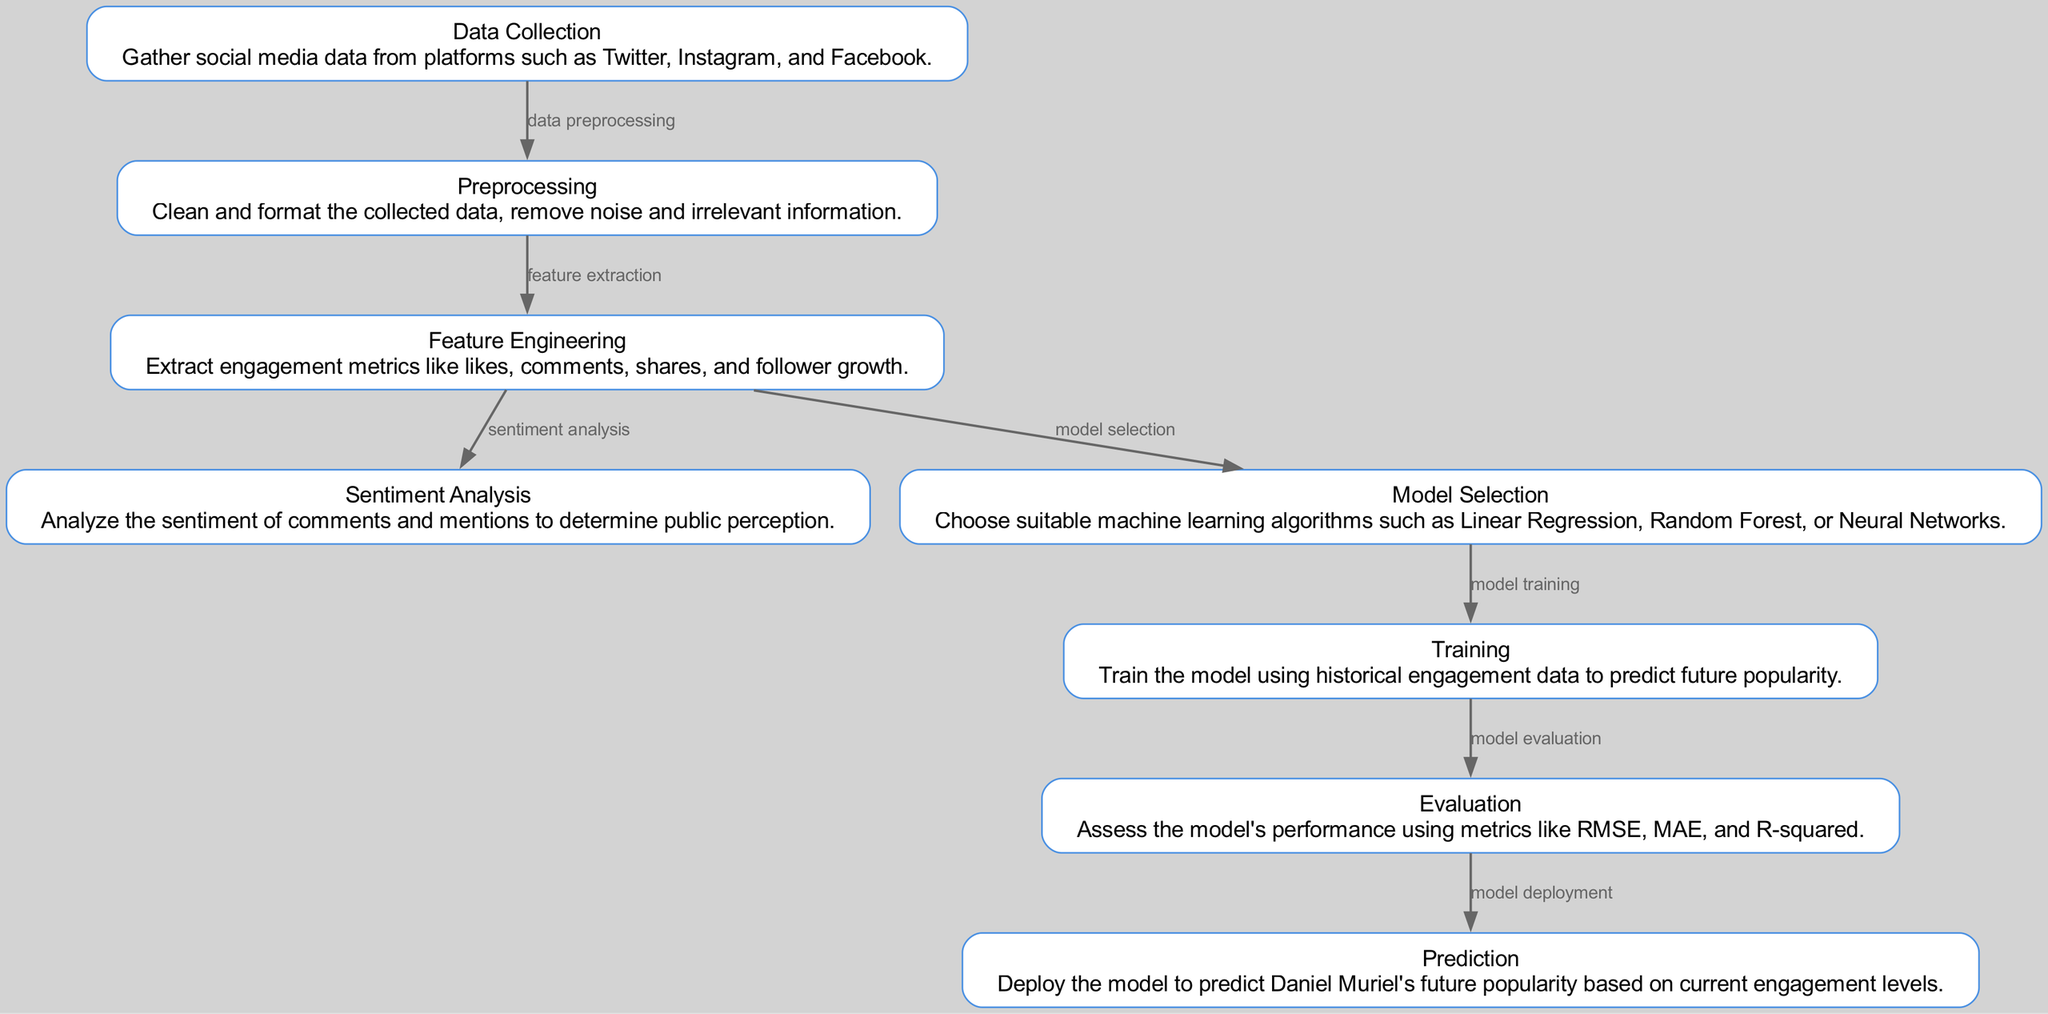What is the first step in the process? The first step or node in the diagram is labeled "Data Collection," which is where the initial gathering of social media data takes place.
Answer: Data Collection How many nodes are in the diagram? By counting the individual nodes listed in the diagram, we find there are a total of eight nodes representing different steps in the machine learning process.
Answer: Eight What is the relationship between the "Preprocessing" and "Feature Engineering" nodes? The diagram shows an edge labeled "feature extraction" connecting "Preprocessing" to "Feature Engineering," indicating that feature engineering occurs after preprocessing.
Answer: feature extraction Which machine learning algorithms are mentioned for model selection? The node labeled "Model Selection" indicates that Linear Regression, Random Forest, and Neural Networks are the suitable machine learning algorithms chosen for this process.
Answer: Linear Regression, Random Forest, Neural Networks What is the final step of the model process? The last node in the diagram, labeled "Prediction," represents the final step where the model is deployed to predict Daniel Muriel's future popularity based on current engagement levels.
Answer: Prediction How does "Sentiment Analysis" relate to "Feature Engineering"? The edge from "Feature Engineering" to "Sentiment Analysis" signifies that after engagement metrics are extracted, sentiment analysis is conducted to understand public perception related to these features.
Answer: Sentiment Analysis What evaluation metrics are used for assessing the model? The node marked "Evaluation" mentions metrics such as RMSE, MAE, and R-squared, which are standard for assessing the performance of regression models in machine learning.
Answer: RMSE, MAE, R-squared Which process follows "Training" in the diagram? The edge leading from "Training" to "Evaluation" indicates that after the model training phase, the following step is to evaluate the model's performance with various metrics.
Answer: Evaluation What is the purpose of the "Feature Engineering" step? The purpose of the "Feature Engineering" step is to extract engagement metrics like likes, comments, shares, and follower growth from the cleaned data, which will be used for model selection and prediction.
Answer: Extract engagement metrics 